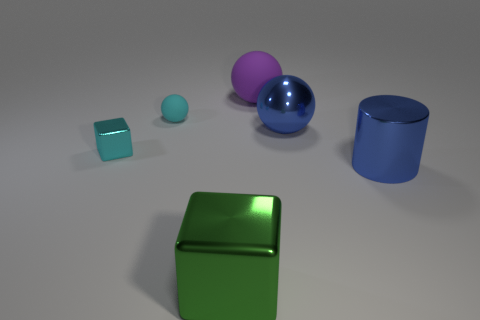Does the matte object on the right side of the green block have the same shape as the large green shiny object?
Provide a short and direct response. No. What number of objects are in front of the small ball and on the left side of the purple thing?
Give a very brief answer. 2. There is a rubber thing left of the purple sphere; what is its shape?
Keep it short and to the point. Sphere. What number of small things are the same material as the large green thing?
Ensure brevity in your answer.  1. There is a tiny metallic object; is it the same shape as the large blue thing on the left side of the blue shiny cylinder?
Offer a terse response. No. Are there any big blue metal cylinders that are left of the cyan shiny object that is in front of the big metal thing that is behind the tiny cyan block?
Ensure brevity in your answer.  No. There is a block that is behind the shiny cylinder; what is its size?
Provide a succinct answer. Small. There is a cyan object that is the same size as the cyan cube; what is it made of?
Ensure brevity in your answer.  Rubber. Do the tiny cyan shiny thing and the purple rubber object have the same shape?
Offer a terse response. No. What number of objects are large blue cylinders or things on the left side of the big cylinder?
Make the answer very short. 6. 